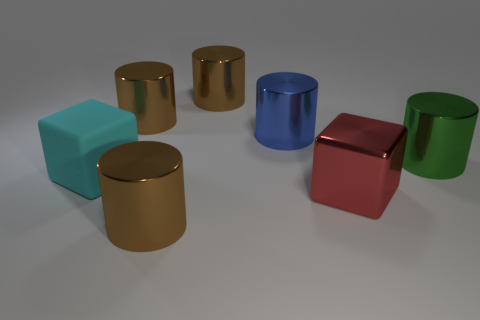Subtract all brown cylinders. How many were subtracted if there are1brown cylinders left? 2 Subtract all purple spheres. How many brown cylinders are left? 3 Subtract all big blue cylinders. How many cylinders are left? 4 Subtract all purple cylinders. Subtract all red spheres. How many cylinders are left? 5 Add 1 big cyan balls. How many objects exist? 8 Subtract all cubes. How many objects are left? 5 Add 4 metallic things. How many metallic things are left? 10 Add 1 cyan matte objects. How many cyan matte objects exist? 2 Subtract 1 green cylinders. How many objects are left? 6 Subtract all brown blocks. Subtract all large blue metallic cylinders. How many objects are left? 6 